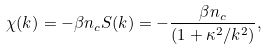Convert formula to latex. <formula><loc_0><loc_0><loc_500><loc_500>\chi ( k ) = - \beta n _ { c } S ( k ) = - \frac { \beta n _ { c } } { ( 1 + \kappa ^ { 2 } / k ^ { 2 } ) } ,</formula> 